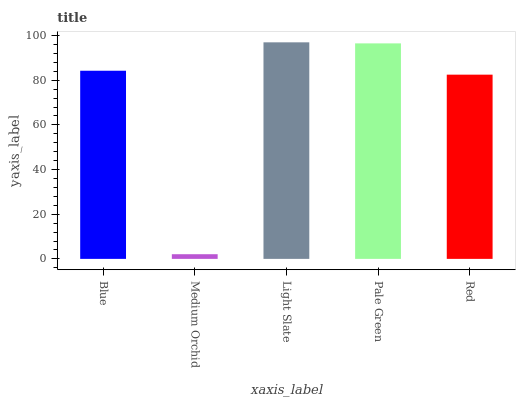Is Medium Orchid the minimum?
Answer yes or no. Yes. Is Light Slate the maximum?
Answer yes or no. Yes. Is Light Slate the minimum?
Answer yes or no. No. Is Medium Orchid the maximum?
Answer yes or no. No. Is Light Slate greater than Medium Orchid?
Answer yes or no. Yes. Is Medium Orchid less than Light Slate?
Answer yes or no. Yes. Is Medium Orchid greater than Light Slate?
Answer yes or no. No. Is Light Slate less than Medium Orchid?
Answer yes or no. No. Is Blue the high median?
Answer yes or no. Yes. Is Blue the low median?
Answer yes or no. Yes. Is Medium Orchid the high median?
Answer yes or no. No. Is Pale Green the low median?
Answer yes or no. No. 